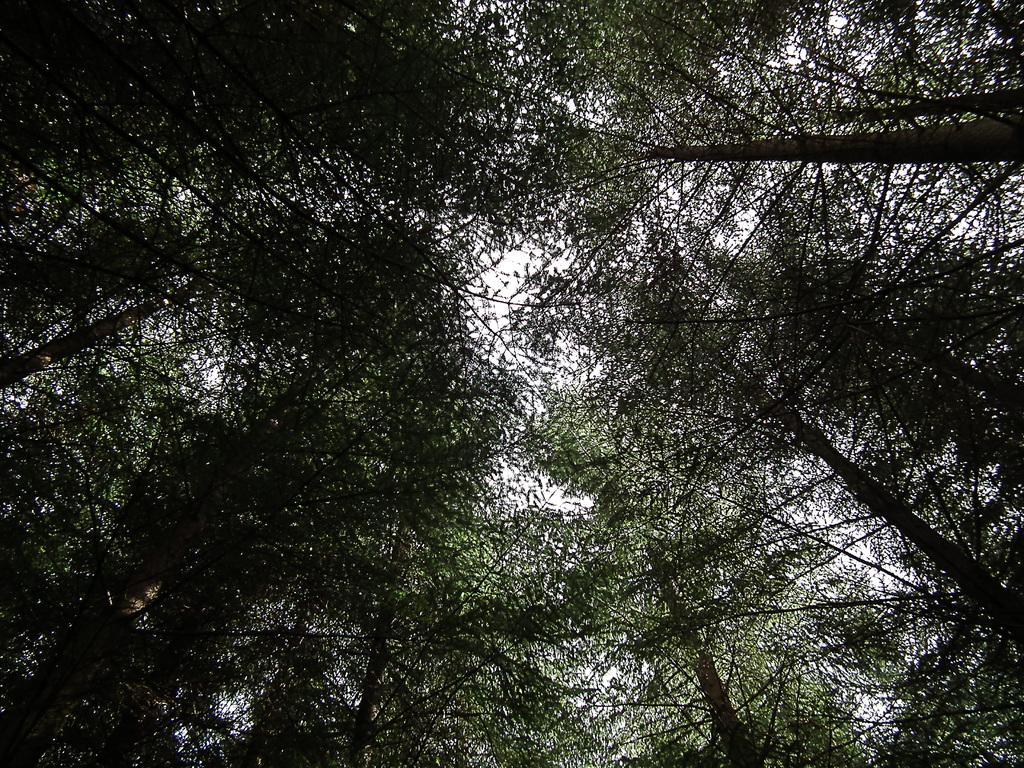What type of vegetation can be seen in the image? There are trees in the image. What is visible at the top of the image? The sky is visible at the top of the image. What sound can be heard coming from the trees in the image? There is no sound present in the image, as it is a still image and not a video or audio recording. How can someone help the trees in the image? The trees in the image do not require any assistance, as they are not living beings and cannot be helped or harmed. 